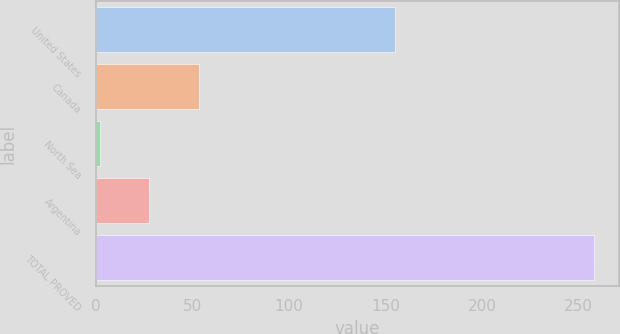<chart> <loc_0><loc_0><loc_500><loc_500><bar_chart><fcel>United States<fcel>Canada<fcel>North Sea<fcel>Argentina<fcel>TOTAL PROVED<nl><fcel>155<fcel>53.2<fcel>2<fcel>27.6<fcel>258<nl></chart> 